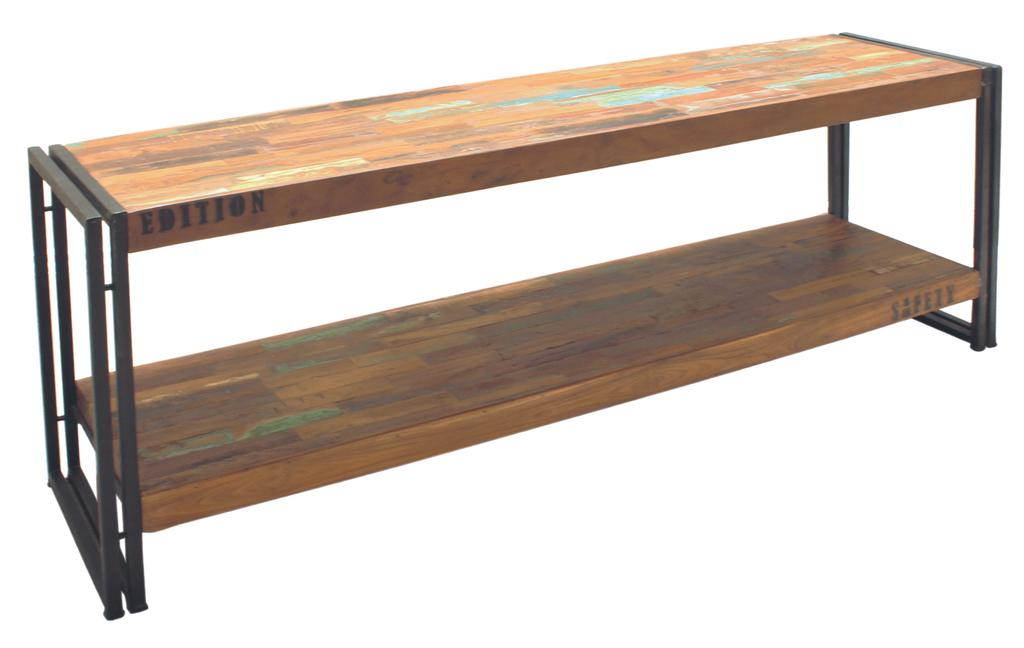<image>
Provide a brief description of the given image. A wooden table that says Edition is on a white background. 